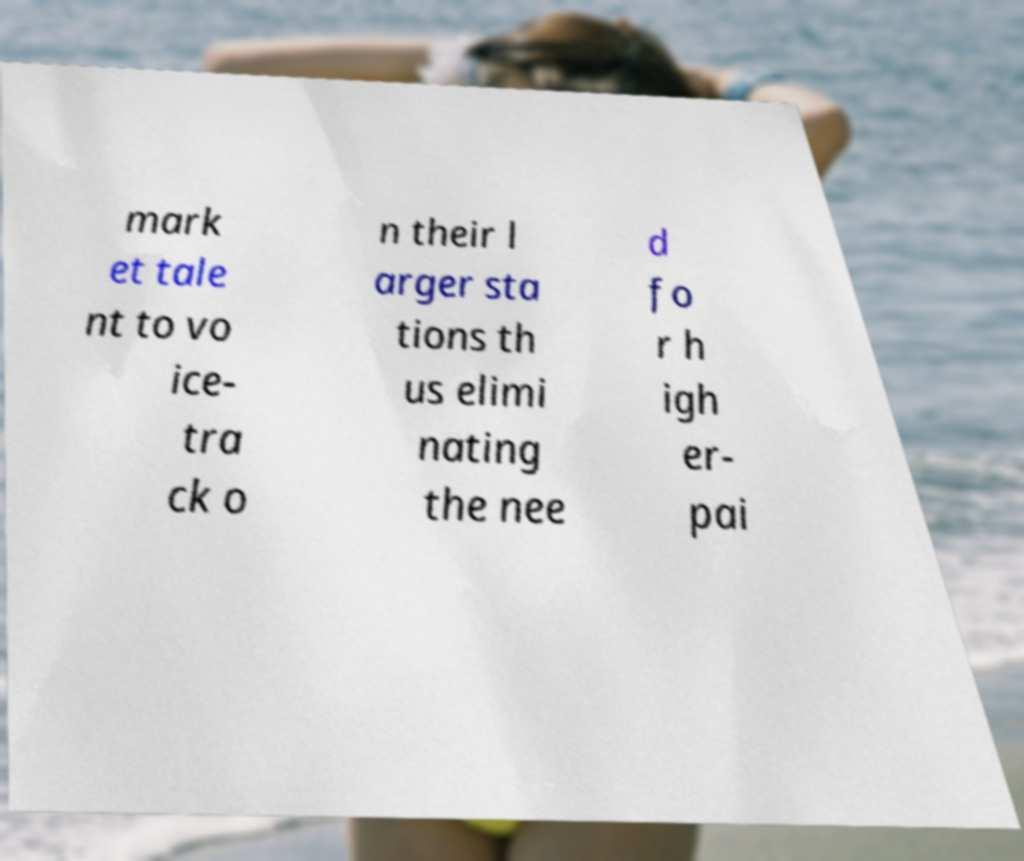Could you assist in decoding the text presented in this image and type it out clearly? mark et tale nt to vo ice- tra ck o n their l arger sta tions th us elimi nating the nee d fo r h igh er- pai 